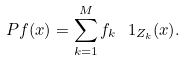<formula> <loc_0><loc_0><loc_500><loc_500>P f ( x ) = \sum _ { k = 1 } ^ { M } f _ { k } \ 1 _ { Z _ { k } } ( x ) .</formula> 